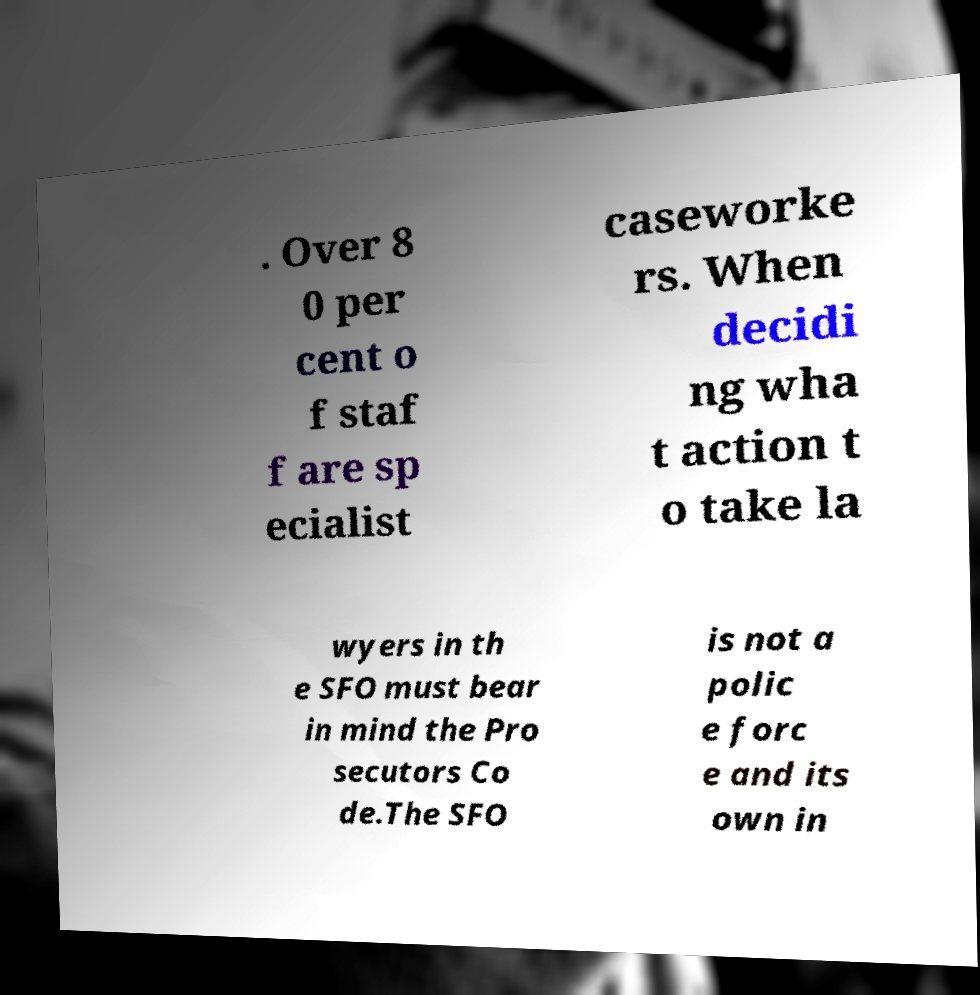There's text embedded in this image that I need extracted. Can you transcribe it verbatim? . Over 8 0 per cent o f staf f are sp ecialist caseworke rs. When decidi ng wha t action t o take la wyers in th e SFO must bear in mind the Pro secutors Co de.The SFO is not a polic e forc e and its own in 